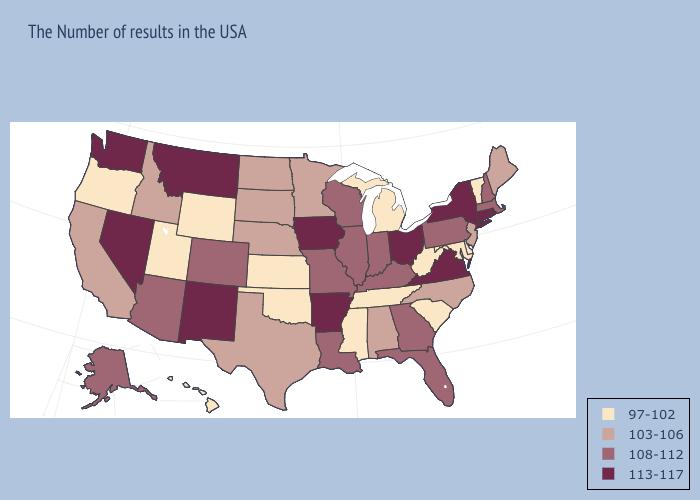Which states have the highest value in the USA?
Be succinct. Rhode Island, Connecticut, New York, Virginia, Ohio, Arkansas, Iowa, New Mexico, Montana, Nevada, Washington. How many symbols are there in the legend?
Write a very short answer. 4. Does Pennsylvania have a higher value than Arkansas?
Answer briefly. No. What is the highest value in the South ?
Answer briefly. 113-117. Does Georgia have the lowest value in the South?
Answer briefly. No. Name the states that have a value in the range 113-117?
Be succinct. Rhode Island, Connecticut, New York, Virginia, Ohio, Arkansas, Iowa, New Mexico, Montana, Nevada, Washington. What is the value of Oklahoma?
Answer briefly. 97-102. Does Oregon have the same value as Utah?
Quick response, please. Yes. Name the states that have a value in the range 97-102?
Concise answer only. Vermont, Delaware, Maryland, South Carolina, West Virginia, Michigan, Tennessee, Mississippi, Kansas, Oklahoma, Wyoming, Utah, Oregon, Hawaii. Does Mississippi have the highest value in the South?
Quick response, please. No. What is the lowest value in states that border New Mexico?
Quick response, please. 97-102. What is the value of Connecticut?
Give a very brief answer. 113-117. Name the states that have a value in the range 103-106?
Short answer required. Maine, New Jersey, North Carolina, Alabama, Minnesota, Nebraska, Texas, South Dakota, North Dakota, Idaho, California. Name the states that have a value in the range 113-117?
Short answer required. Rhode Island, Connecticut, New York, Virginia, Ohio, Arkansas, Iowa, New Mexico, Montana, Nevada, Washington. Does Ohio have the highest value in the USA?
Answer briefly. Yes. 